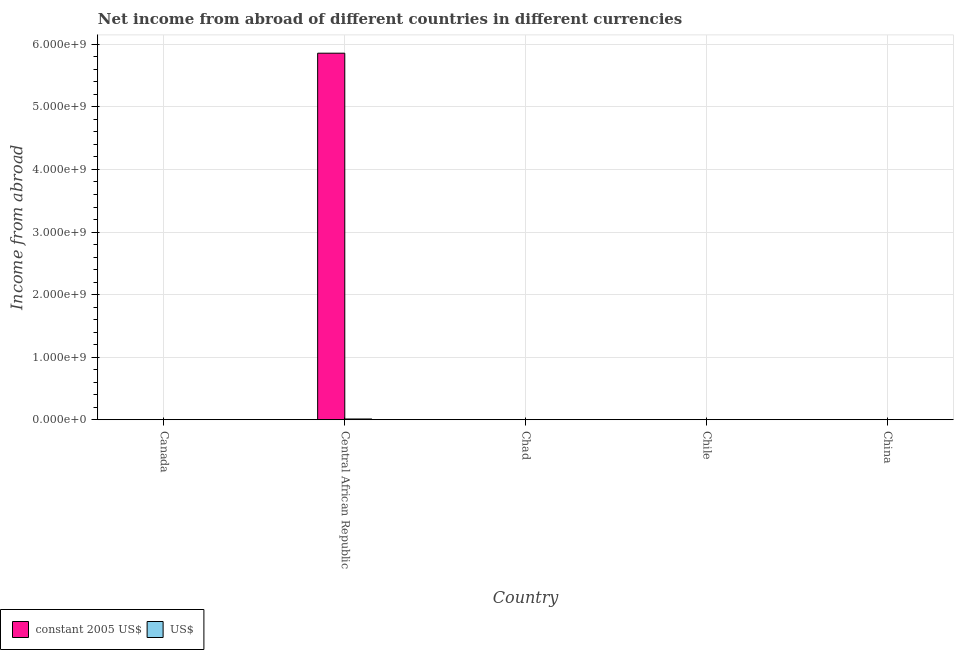Are the number of bars per tick equal to the number of legend labels?
Make the answer very short. No. How many bars are there on the 3rd tick from the left?
Keep it short and to the point. 0. How many bars are there on the 4th tick from the right?
Your answer should be very brief. 2. What is the label of the 1st group of bars from the left?
Give a very brief answer. Canada. In how many cases, is the number of bars for a given country not equal to the number of legend labels?
Keep it short and to the point. 4. What is the income from abroad in constant 2005 us$ in Central African Republic?
Ensure brevity in your answer.  5.86e+09. Across all countries, what is the maximum income from abroad in us$?
Keep it short and to the point. 1.15e+07. Across all countries, what is the minimum income from abroad in constant 2005 us$?
Provide a succinct answer. 0. In which country was the income from abroad in constant 2005 us$ maximum?
Your answer should be compact. Central African Republic. What is the total income from abroad in us$ in the graph?
Offer a very short reply. 1.15e+07. What is the difference between the income from abroad in us$ in China and the income from abroad in constant 2005 us$ in Chile?
Offer a very short reply. 0. What is the average income from abroad in constant 2005 us$ per country?
Provide a succinct answer. 1.17e+09. What is the difference between the income from abroad in constant 2005 us$ and income from abroad in us$ in Central African Republic?
Offer a very short reply. 5.85e+09. What is the difference between the highest and the lowest income from abroad in constant 2005 us$?
Your answer should be very brief. 5.86e+09. How many bars are there?
Give a very brief answer. 2. Are the values on the major ticks of Y-axis written in scientific E-notation?
Offer a terse response. Yes. Does the graph contain any zero values?
Provide a short and direct response. Yes. Does the graph contain grids?
Provide a succinct answer. Yes. How many legend labels are there?
Give a very brief answer. 2. What is the title of the graph?
Offer a terse response. Net income from abroad of different countries in different currencies. What is the label or title of the X-axis?
Offer a terse response. Country. What is the label or title of the Y-axis?
Provide a succinct answer. Income from abroad. What is the Income from abroad in constant 2005 US$ in Central African Republic?
Provide a succinct answer. 5.86e+09. What is the Income from abroad in US$ in Central African Republic?
Your answer should be compact. 1.15e+07. What is the Income from abroad of constant 2005 US$ in Chad?
Your answer should be very brief. 0. What is the Income from abroad of US$ in Chad?
Your response must be concise. 0. What is the Income from abroad in constant 2005 US$ in Chile?
Give a very brief answer. 0. What is the Income from abroad in US$ in Chile?
Give a very brief answer. 0. What is the Income from abroad in constant 2005 US$ in China?
Provide a succinct answer. 0. Across all countries, what is the maximum Income from abroad in constant 2005 US$?
Offer a terse response. 5.86e+09. Across all countries, what is the maximum Income from abroad in US$?
Give a very brief answer. 1.15e+07. What is the total Income from abroad of constant 2005 US$ in the graph?
Your answer should be compact. 5.86e+09. What is the total Income from abroad in US$ in the graph?
Offer a very short reply. 1.15e+07. What is the average Income from abroad of constant 2005 US$ per country?
Your response must be concise. 1.17e+09. What is the average Income from abroad of US$ per country?
Keep it short and to the point. 2.30e+06. What is the difference between the Income from abroad of constant 2005 US$ and Income from abroad of US$ in Central African Republic?
Your response must be concise. 5.85e+09. What is the difference between the highest and the lowest Income from abroad in constant 2005 US$?
Offer a terse response. 5.86e+09. What is the difference between the highest and the lowest Income from abroad in US$?
Your answer should be very brief. 1.15e+07. 